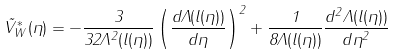<formula> <loc_0><loc_0><loc_500><loc_500>\tilde { V } _ { W } ^ { * } ( \eta ) = - \frac { 3 } { 3 2 \Lambda ^ { 2 } ( l ( \eta ) ) } \left ( \frac { d \Lambda ( l ( \eta ) ) } { d \eta } \right ) ^ { 2 } + \frac { 1 } { 8 \Lambda ( l ( \eta ) ) } \frac { d ^ { 2 } \Lambda ( l ( \eta ) ) } { d \eta ^ { 2 } }</formula> 